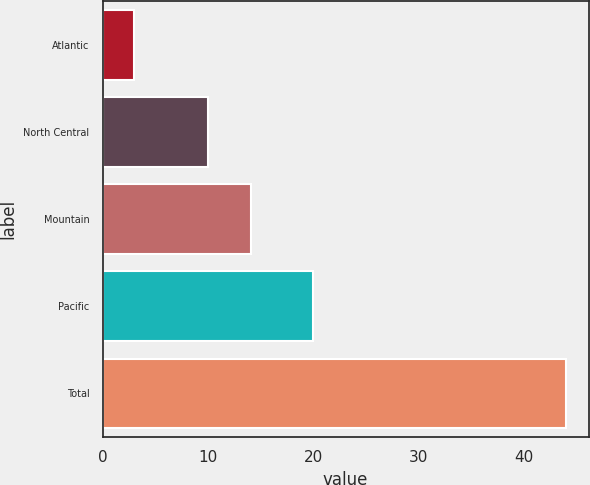<chart> <loc_0><loc_0><loc_500><loc_500><bar_chart><fcel>Atlantic<fcel>North Central<fcel>Mountain<fcel>Pacific<fcel>Total<nl><fcel>3<fcel>10<fcel>14.1<fcel>20<fcel>44<nl></chart> 